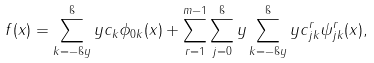Convert formula to latex. <formula><loc_0><loc_0><loc_500><loc_500>f ( x ) = \sum _ { k = - \i y } ^ { \i } y c _ { k } \phi _ { 0 k } ( x ) + \sum _ { r = 1 } ^ { m - 1 } \sum _ { j = 0 } ^ { \i } y \sum _ { k = - \i y } ^ { \i } y c ^ { r } _ { j k } \psi ^ { r } _ { j k } ( x ) ,</formula> 